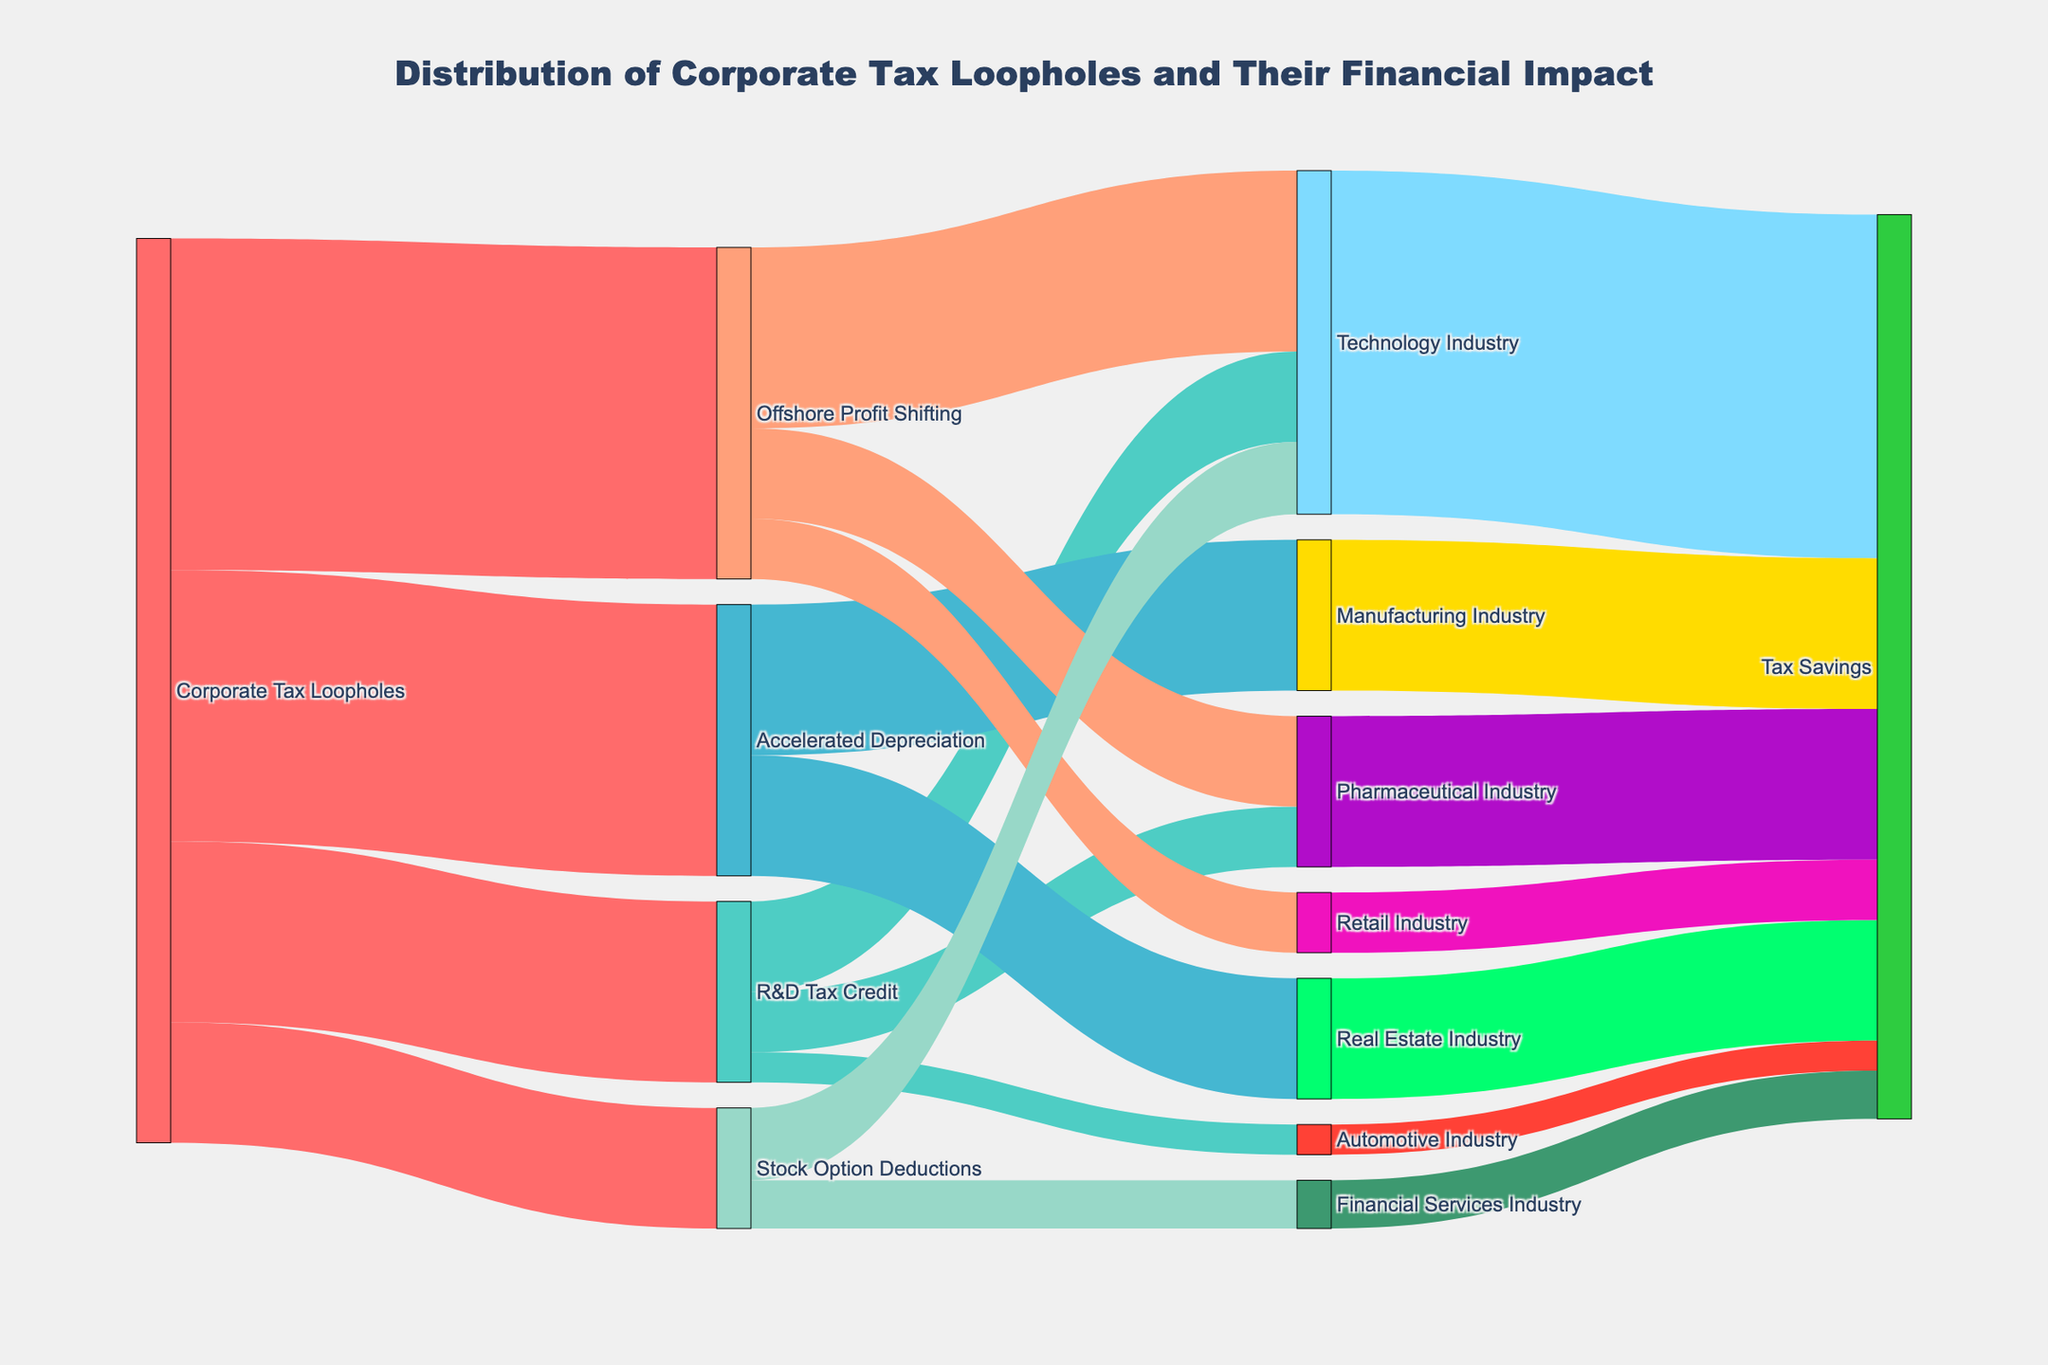What is the title of the Sankey diagram? The title of the Sankey diagram is usually displayed prominently at the top. In this case, the title is "Distribution of Corporate Tax Loopholes and Their Financial Impact".
Answer: Distribution of Corporate Tax Loopholes and Their Financial Impact Which industry benefits the most from offshore profit shifting in terms of tax savings? By following the link from "Offshore Profit Shifting" to its targets, you will see that the "Technology Industry" benefits the most with a value of 30.
Answer: Technology Industry What is the total value of tax savings for the Technology Industry from all loopholes combined? The Technology Industry gains from "R&D Tax Credit" (15), "Offshore Profit Shifting" (30), and "Stock Option Deductions" (12). Summing these values, we get 15 + 30 + 12 = 57.
Answer: 57 How much tax savings does the Manufacturing Industry receive through accelerated depreciation? Trace the link from "Accelerated Depreciation" to "Manufacturing Industry" to find that the value is 25.
Answer: 25 Compare the tax savings of the Pharmaceutical Industry from R&D Tax Credit and Offshore Profit Shifting. Which is higher? Follow the links from "R&D Tax Credit" and "Offshore Profit Shifting" to "Pharmaceutical Industry". The value for R&D Tax Credit is 10 and for Offshore Profit Shifting is 15. Offshore Profit Shifting is higher with a value of 15.
Answer: Offshore Profit Shifting What is the combined value of tax savings for industries categorized under R&D Tax Credit? The "R&D Tax Credit" affects the Technology Industry (15), Pharmaceutical Industry (10), and Automotive Industry (5). Adding these together: 15 + 10 + 5 = 30.
Answer: 30 Which industry receives the lowest tax savings and through which loophole(s)? By examining the values for each industry through various loopholes, we see that the Automotive Industry receives the lowest, with a value of 5 from the R&D Tax Credit.
Answer: Automotive Industry via R&D Tax Credit Identify the industry benefiting exclusively from a single loophole and name the loophole. The Financial Services Industry benefits exclusively from "Stock Option Deductions" with a value of 8, as there are no other connections to it.
Answer: Financial Services Industry, Stock Option Deductions What is the total value of loopholes originating from Corporate Tax Loopholes? The values for the main loopholes from Corporate Tax Loopholes are R&D Tax Credit (30), Accelerated Depreciation (45), Offshore Profit Shifting (55), and Stock Option Deductions (20). Summing these: 30 + 45 + 55 + 20 = 150.
Answer: 150 